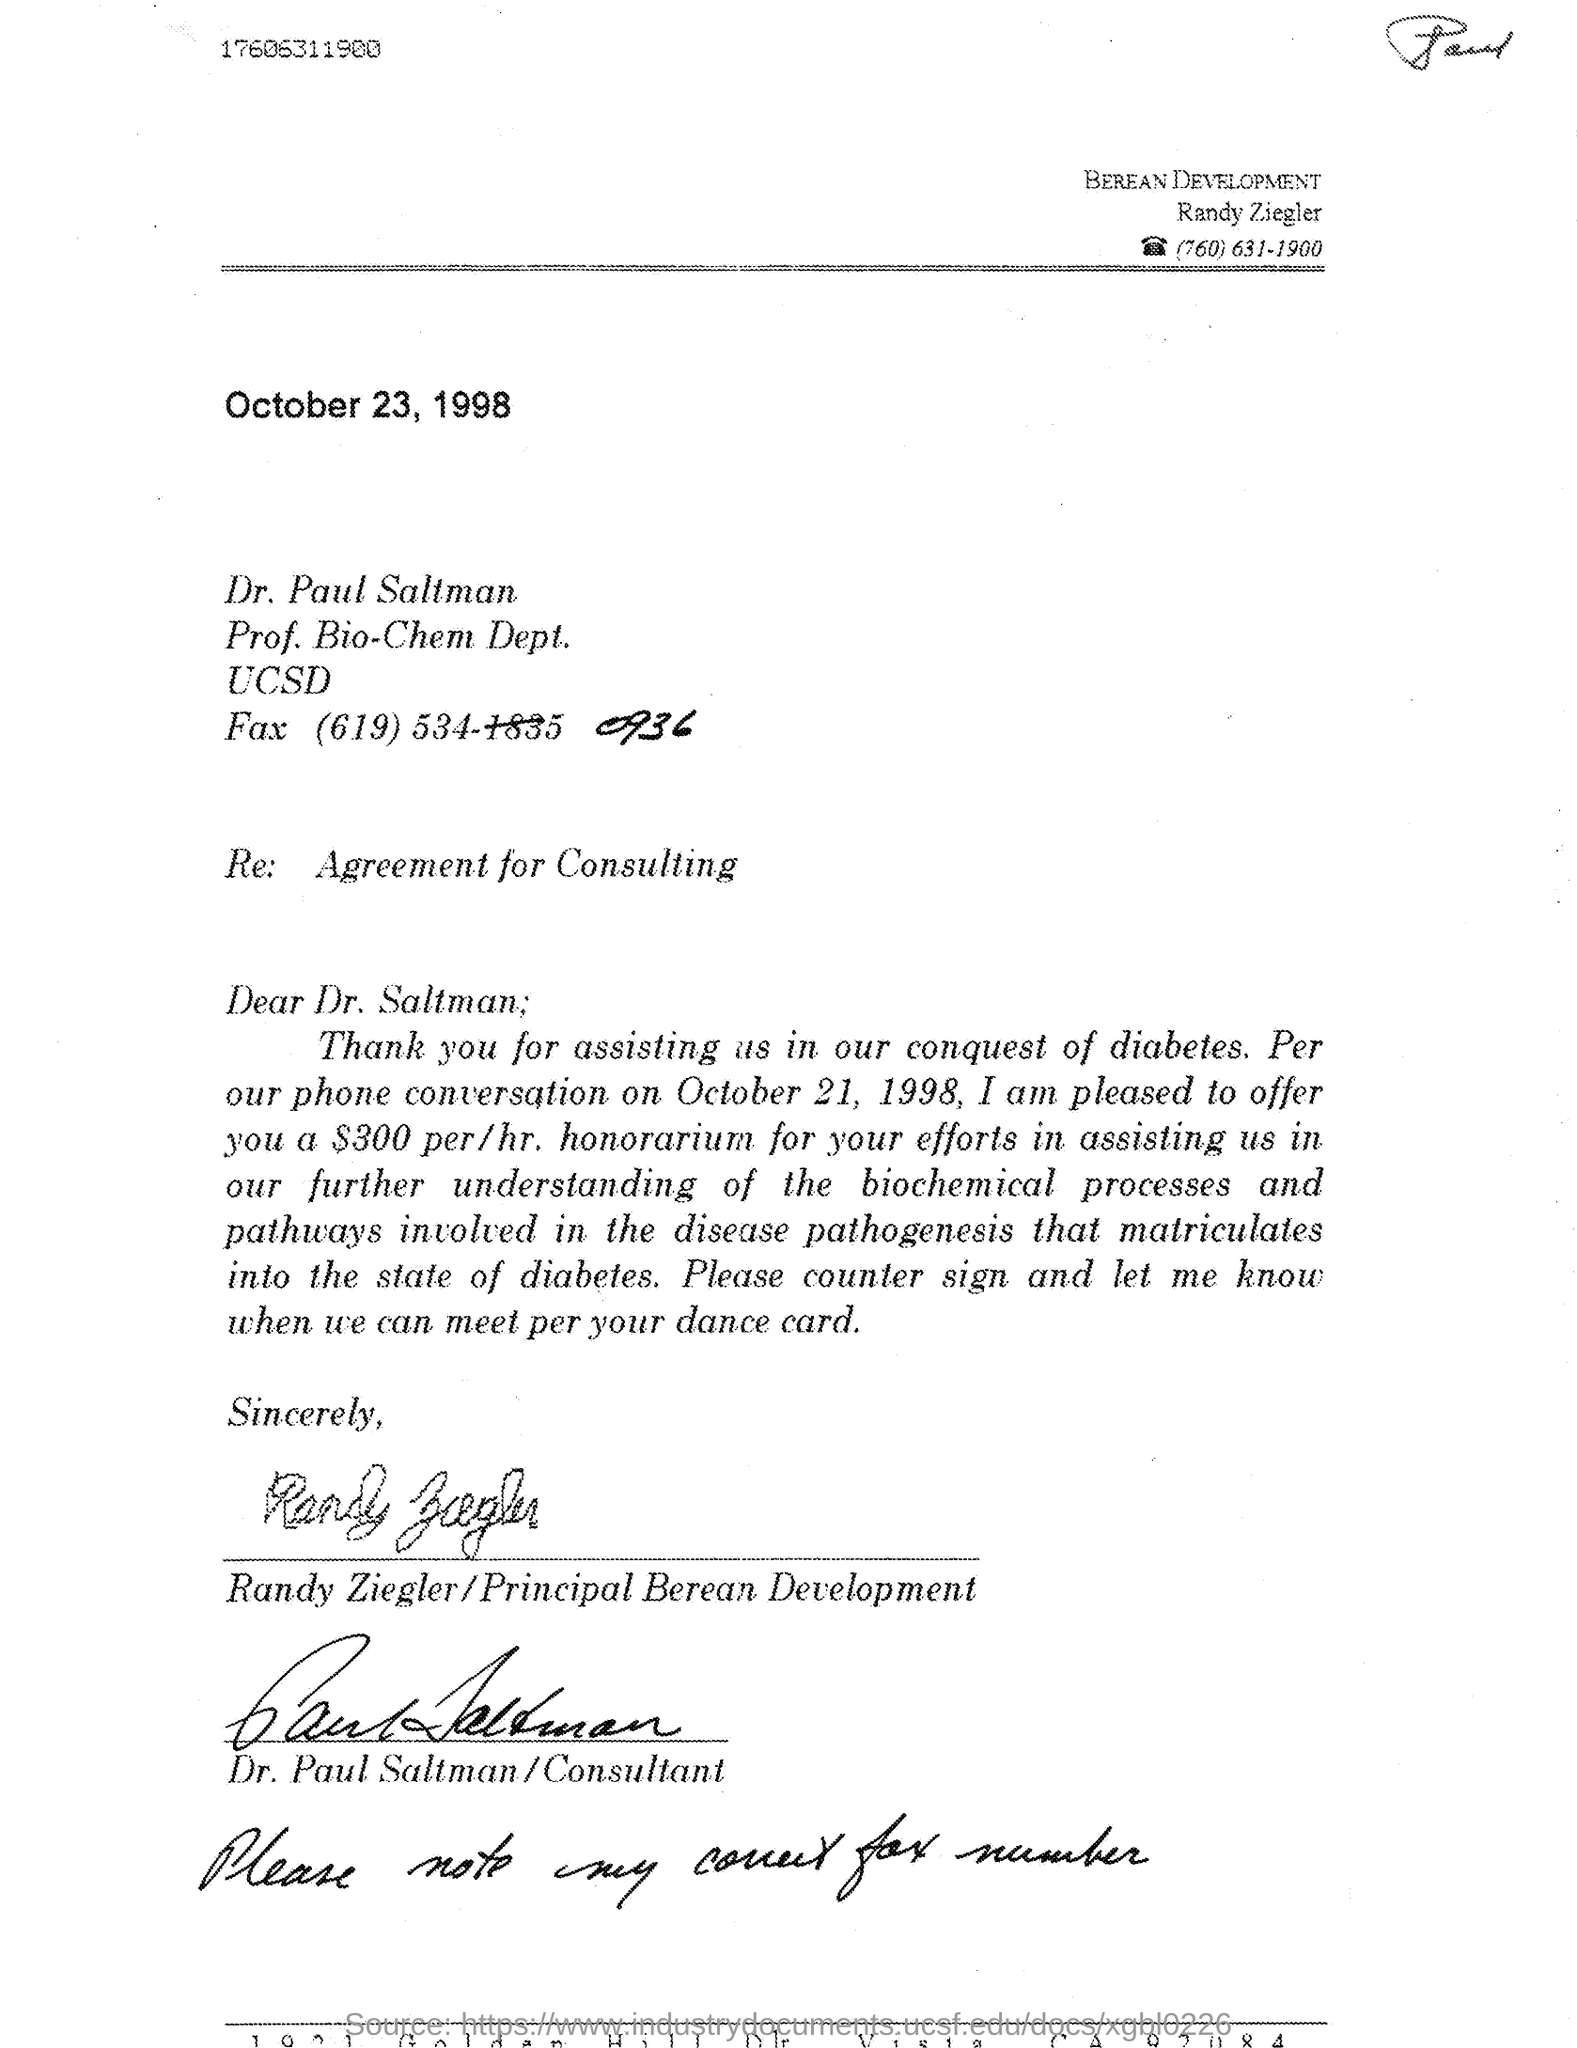What is the designation of Randy Ziegler?
Make the answer very short. Principal Berean Development. What is the fax no of Dr. Paul Saltman?
Make the answer very short. (619) 534-0936. What is the phone no of Randy Ziegler mentioned in the letterhead?
Provide a short and direct response. (760) 631-1900. What is the issued date of the letter?
Your response must be concise. October 23, 1998. 